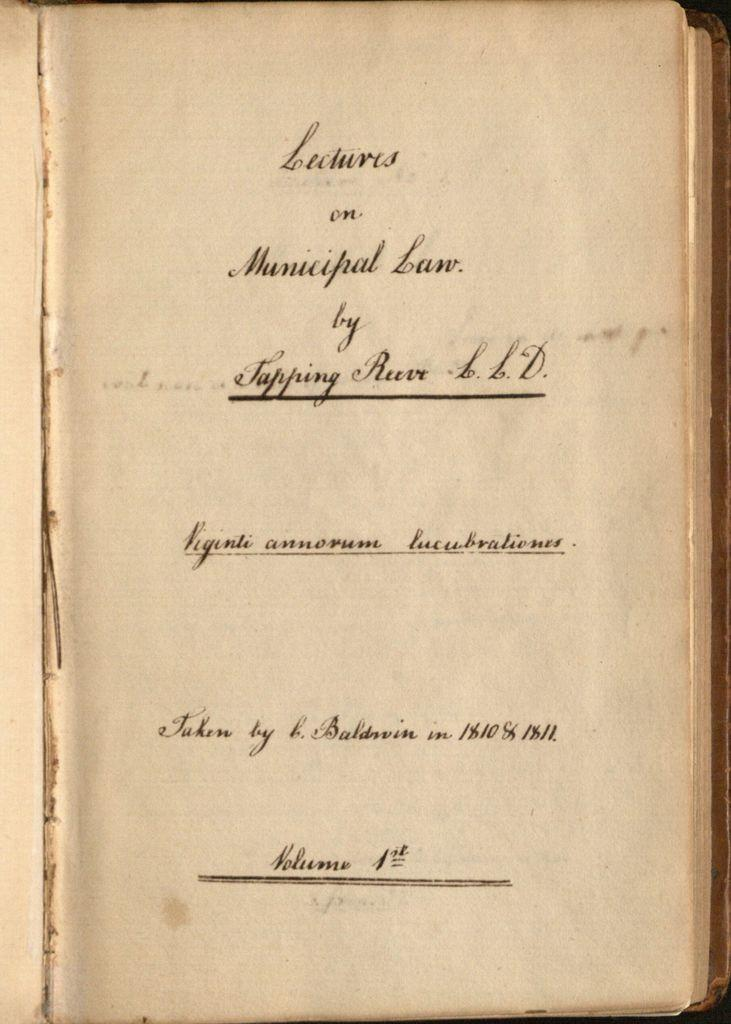<image>
Give a short and clear explanation of the subsequent image. Lectures on Municipal Law Volume 1 was written by Tapping Reeve. 